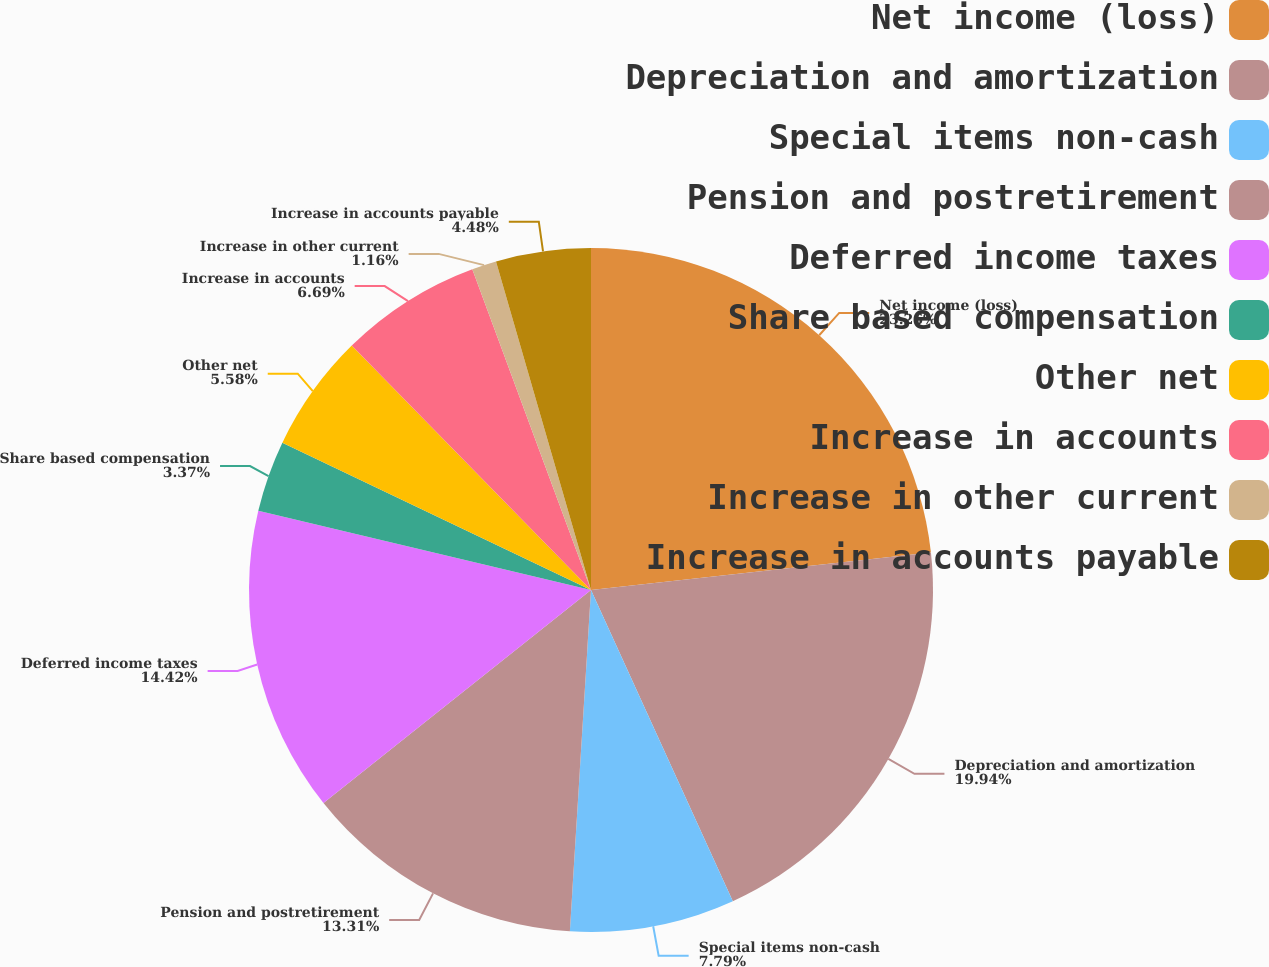<chart> <loc_0><loc_0><loc_500><loc_500><pie_chart><fcel>Net income (loss)<fcel>Depreciation and amortization<fcel>Special items non-cash<fcel>Pension and postretirement<fcel>Deferred income taxes<fcel>Share based compensation<fcel>Other net<fcel>Increase in accounts<fcel>Increase in other current<fcel>Increase in accounts payable<nl><fcel>23.25%<fcel>19.94%<fcel>7.79%<fcel>13.31%<fcel>14.42%<fcel>3.37%<fcel>5.58%<fcel>6.69%<fcel>1.16%<fcel>4.48%<nl></chart> 